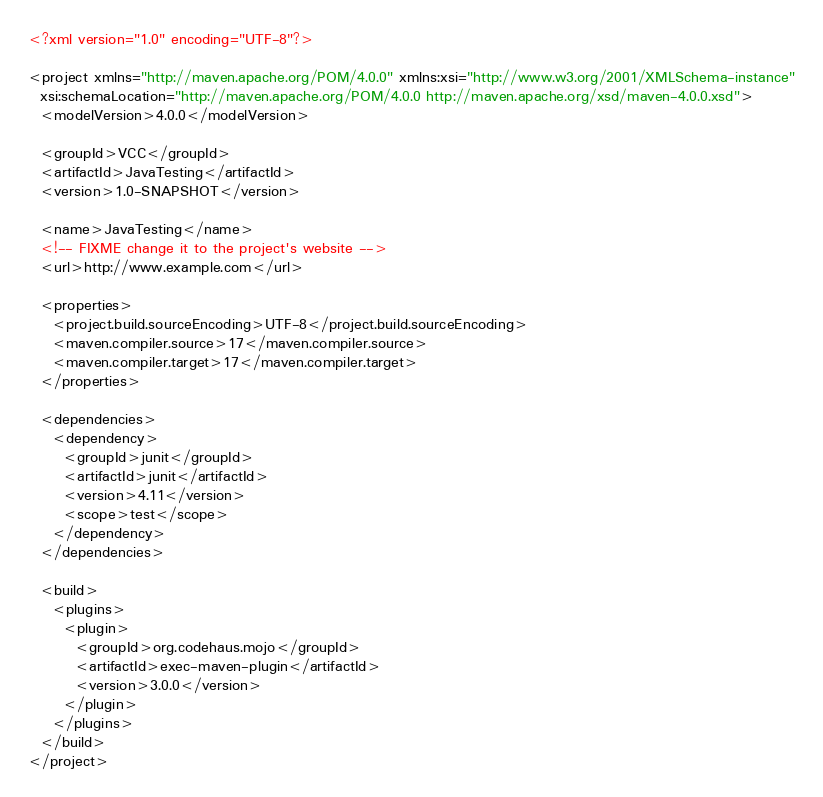Convert code to text. <code><loc_0><loc_0><loc_500><loc_500><_XML_><?xml version="1.0" encoding="UTF-8"?>

<project xmlns="http://maven.apache.org/POM/4.0.0" xmlns:xsi="http://www.w3.org/2001/XMLSchema-instance"
  xsi:schemaLocation="http://maven.apache.org/POM/4.0.0 http://maven.apache.org/xsd/maven-4.0.0.xsd">
  <modelVersion>4.0.0</modelVersion>

  <groupId>VCC</groupId>
  <artifactId>JavaTesting</artifactId>
  <version>1.0-SNAPSHOT</version>

  <name>JavaTesting</name>
  <!-- FIXME change it to the project's website -->
  <url>http://www.example.com</url>

  <properties>
    <project.build.sourceEncoding>UTF-8</project.build.sourceEncoding>
    <maven.compiler.source>17</maven.compiler.source>
    <maven.compiler.target>17</maven.compiler.target>
  </properties>

  <dependencies>
    <dependency>
      <groupId>junit</groupId>
      <artifactId>junit</artifactId>
      <version>4.11</version>
      <scope>test</scope>
    </dependency>
  </dependencies>

  <build>
    <plugins>
      <plugin>
        <groupId>org.codehaus.mojo</groupId>
        <artifactId>exec-maven-plugin</artifactId>
        <version>3.0.0</version>
      </plugin>
    </plugins>
  </build>
</project>
</code> 